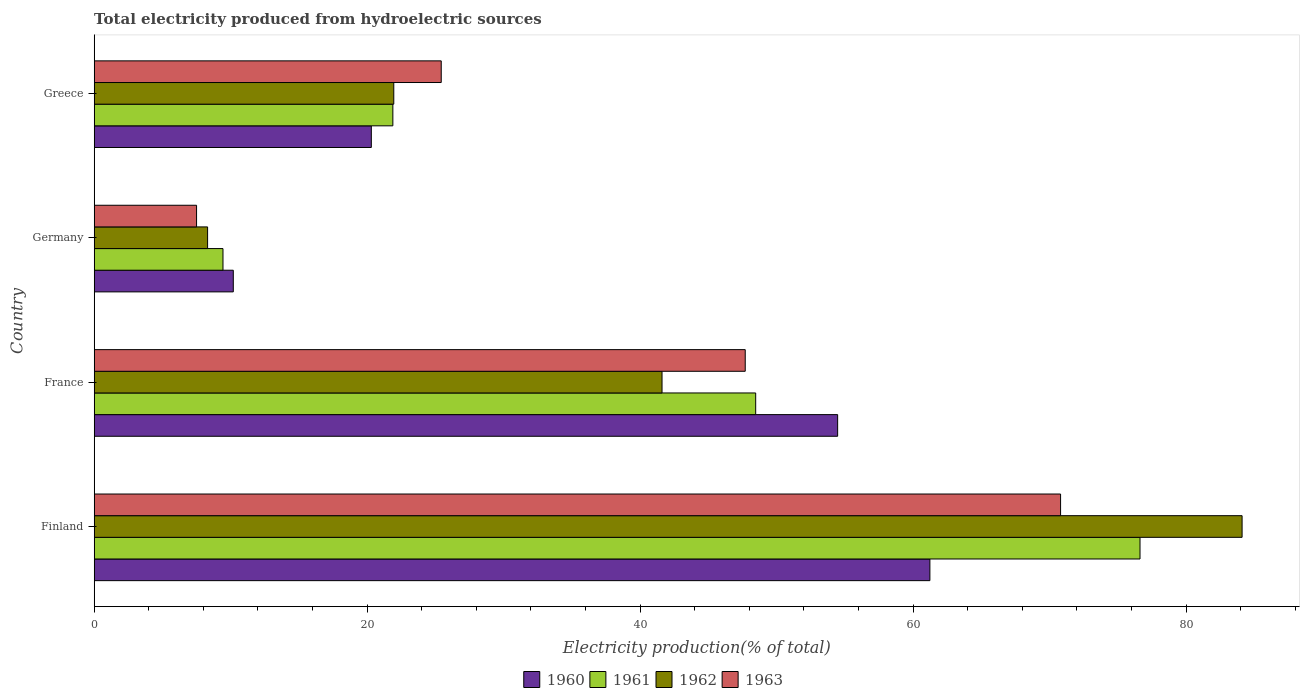How many different coloured bars are there?
Provide a succinct answer. 4. How many groups of bars are there?
Your response must be concise. 4. Are the number of bars on each tick of the Y-axis equal?
Keep it short and to the point. Yes. How many bars are there on the 3rd tick from the top?
Keep it short and to the point. 4. What is the label of the 2nd group of bars from the top?
Provide a short and direct response. Germany. What is the total electricity produced in 1962 in Greece?
Make the answer very short. 21.95. Across all countries, what is the maximum total electricity produced in 1963?
Offer a very short reply. 70.81. Across all countries, what is the minimum total electricity produced in 1963?
Make the answer very short. 7.5. In which country was the total electricity produced in 1963 minimum?
Make the answer very short. Germany. What is the total total electricity produced in 1960 in the graph?
Your response must be concise. 146.2. What is the difference between the total electricity produced in 1963 in Finland and that in France?
Make the answer very short. 23.11. What is the difference between the total electricity produced in 1961 in France and the total electricity produced in 1963 in Finland?
Give a very brief answer. -22.34. What is the average total electricity produced in 1963 per country?
Give a very brief answer. 37.86. What is the difference between the total electricity produced in 1960 and total electricity produced in 1961 in Germany?
Your response must be concise. 0.76. In how many countries, is the total electricity produced in 1960 greater than 84 %?
Keep it short and to the point. 0. What is the ratio of the total electricity produced in 1963 in Finland to that in Germany?
Your answer should be compact. 9.44. What is the difference between the highest and the second highest total electricity produced in 1961?
Your answer should be compact. 28.16. What is the difference between the highest and the lowest total electricity produced in 1962?
Ensure brevity in your answer.  75.8. Is the sum of the total electricity produced in 1960 in Finland and Greece greater than the maximum total electricity produced in 1963 across all countries?
Your answer should be very brief. Yes. What does the 1st bar from the top in France represents?
Your answer should be compact. 1963. Is it the case that in every country, the sum of the total electricity produced in 1960 and total electricity produced in 1963 is greater than the total electricity produced in 1962?
Give a very brief answer. Yes. How many countries are there in the graph?
Your answer should be compact. 4. Where does the legend appear in the graph?
Make the answer very short. Bottom center. How many legend labels are there?
Your response must be concise. 4. How are the legend labels stacked?
Make the answer very short. Horizontal. What is the title of the graph?
Offer a very short reply. Total electricity produced from hydroelectric sources. What is the label or title of the X-axis?
Your answer should be very brief. Electricity production(% of total). What is the label or title of the Y-axis?
Make the answer very short. Country. What is the Electricity production(% of total) in 1960 in Finland?
Give a very brief answer. 61.23. What is the Electricity production(% of total) of 1961 in Finland?
Your response must be concise. 76.63. What is the Electricity production(% of total) in 1962 in Finland?
Your answer should be compact. 84.11. What is the Electricity production(% of total) of 1963 in Finland?
Provide a short and direct response. 70.81. What is the Electricity production(% of total) of 1960 in France?
Offer a very short reply. 54.47. What is the Electricity production(% of total) of 1961 in France?
Make the answer very short. 48.47. What is the Electricity production(% of total) in 1962 in France?
Keep it short and to the point. 41.61. What is the Electricity production(% of total) of 1963 in France?
Your response must be concise. 47.7. What is the Electricity production(% of total) in 1960 in Germany?
Give a very brief answer. 10.19. What is the Electricity production(% of total) in 1961 in Germany?
Offer a very short reply. 9.44. What is the Electricity production(% of total) of 1962 in Germany?
Your answer should be very brief. 8.31. What is the Electricity production(% of total) in 1963 in Germany?
Keep it short and to the point. 7.5. What is the Electricity production(% of total) of 1960 in Greece?
Keep it short and to the point. 20.31. What is the Electricity production(% of total) of 1961 in Greece?
Your answer should be very brief. 21.88. What is the Electricity production(% of total) of 1962 in Greece?
Ensure brevity in your answer.  21.95. What is the Electricity production(% of total) in 1963 in Greece?
Provide a short and direct response. 25.43. Across all countries, what is the maximum Electricity production(% of total) of 1960?
Keep it short and to the point. 61.23. Across all countries, what is the maximum Electricity production(% of total) of 1961?
Provide a succinct answer. 76.63. Across all countries, what is the maximum Electricity production(% of total) in 1962?
Your answer should be very brief. 84.11. Across all countries, what is the maximum Electricity production(% of total) of 1963?
Your answer should be compact. 70.81. Across all countries, what is the minimum Electricity production(% of total) of 1960?
Your answer should be compact. 10.19. Across all countries, what is the minimum Electricity production(% of total) in 1961?
Provide a succinct answer. 9.44. Across all countries, what is the minimum Electricity production(% of total) of 1962?
Provide a short and direct response. 8.31. Across all countries, what is the minimum Electricity production(% of total) in 1963?
Give a very brief answer. 7.5. What is the total Electricity production(% of total) of 1960 in the graph?
Your answer should be compact. 146.2. What is the total Electricity production(% of total) in 1961 in the graph?
Offer a very short reply. 156.42. What is the total Electricity production(% of total) in 1962 in the graph?
Your answer should be compact. 155.97. What is the total Electricity production(% of total) of 1963 in the graph?
Provide a succinct answer. 151.44. What is the difference between the Electricity production(% of total) in 1960 in Finland and that in France?
Your answer should be compact. 6.76. What is the difference between the Electricity production(% of total) in 1961 in Finland and that in France?
Keep it short and to the point. 28.16. What is the difference between the Electricity production(% of total) in 1962 in Finland and that in France?
Make the answer very short. 42.5. What is the difference between the Electricity production(% of total) of 1963 in Finland and that in France?
Provide a succinct answer. 23.11. What is the difference between the Electricity production(% of total) in 1960 in Finland and that in Germany?
Ensure brevity in your answer.  51.04. What is the difference between the Electricity production(% of total) of 1961 in Finland and that in Germany?
Offer a very short reply. 67.19. What is the difference between the Electricity production(% of total) of 1962 in Finland and that in Germany?
Your answer should be compact. 75.8. What is the difference between the Electricity production(% of total) in 1963 in Finland and that in Germany?
Give a very brief answer. 63.31. What is the difference between the Electricity production(% of total) in 1960 in Finland and that in Greece?
Make the answer very short. 40.93. What is the difference between the Electricity production(% of total) of 1961 in Finland and that in Greece?
Make the answer very short. 54.75. What is the difference between the Electricity production(% of total) of 1962 in Finland and that in Greece?
Your response must be concise. 62.16. What is the difference between the Electricity production(% of total) in 1963 in Finland and that in Greece?
Offer a very short reply. 45.38. What is the difference between the Electricity production(% of total) of 1960 in France and that in Germany?
Ensure brevity in your answer.  44.28. What is the difference between the Electricity production(% of total) in 1961 in France and that in Germany?
Provide a succinct answer. 39.03. What is the difference between the Electricity production(% of total) of 1962 in France and that in Germany?
Your response must be concise. 33.3. What is the difference between the Electricity production(% of total) in 1963 in France and that in Germany?
Your answer should be compact. 40.2. What is the difference between the Electricity production(% of total) of 1960 in France and that in Greece?
Your response must be concise. 34.17. What is the difference between the Electricity production(% of total) in 1961 in France and that in Greece?
Ensure brevity in your answer.  26.58. What is the difference between the Electricity production(% of total) in 1962 in France and that in Greece?
Give a very brief answer. 19.66. What is the difference between the Electricity production(% of total) in 1963 in France and that in Greece?
Your response must be concise. 22.27. What is the difference between the Electricity production(% of total) in 1960 in Germany and that in Greece?
Ensure brevity in your answer.  -10.11. What is the difference between the Electricity production(% of total) in 1961 in Germany and that in Greece?
Give a very brief answer. -12.45. What is the difference between the Electricity production(% of total) in 1962 in Germany and that in Greece?
Offer a terse response. -13.64. What is the difference between the Electricity production(% of total) in 1963 in Germany and that in Greece?
Offer a very short reply. -17.93. What is the difference between the Electricity production(% of total) of 1960 in Finland and the Electricity production(% of total) of 1961 in France?
Ensure brevity in your answer.  12.76. What is the difference between the Electricity production(% of total) in 1960 in Finland and the Electricity production(% of total) in 1962 in France?
Give a very brief answer. 19.63. What is the difference between the Electricity production(% of total) of 1960 in Finland and the Electricity production(% of total) of 1963 in France?
Offer a very short reply. 13.53. What is the difference between the Electricity production(% of total) of 1961 in Finland and the Electricity production(% of total) of 1962 in France?
Your answer should be compact. 35.02. What is the difference between the Electricity production(% of total) of 1961 in Finland and the Electricity production(% of total) of 1963 in France?
Offer a very short reply. 28.93. What is the difference between the Electricity production(% of total) in 1962 in Finland and the Electricity production(% of total) in 1963 in France?
Offer a very short reply. 36.41. What is the difference between the Electricity production(% of total) in 1960 in Finland and the Electricity production(% of total) in 1961 in Germany?
Make the answer very short. 51.8. What is the difference between the Electricity production(% of total) of 1960 in Finland and the Electricity production(% of total) of 1962 in Germany?
Your answer should be compact. 52.92. What is the difference between the Electricity production(% of total) in 1960 in Finland and the Electricity production(% of total) in 1963 in Germany?
Your response must be concise. 53.73. What is the difference between the Electricity production(% of total) in 1961 in Finland and the Electricity production(% of total) in 1962 in Germany?
Your answer should be very brief. 68.32. What is the difference between the Electricity production(% of total) in 1961 in Finland and the Electricity production(% of total) in 1963 in Germany?
Ensure brevity in your answer.  69.13. What is the difference between the Electricity production(% of total) of 1962 in Finland and the Electricity production(% of total) of 1963 in Germany?
Your answer should be very brief. 76.61. What is the difference between the Electricity production(% of total) of 1960 in Finland and the Electricity production(% of total) of 1961 in Greece?
Give a very brief answer. 39.35. What is the difference between the Electricity production(% of total) of 1960 in Finland and the Electricity production(% of total) of 1962 in Greece?
Keep it short and to the point. 39.28. What is the difference between the Electricity production(% of total) of 1960 in Finland and the Electricity production(% of total) of 1963 in Greece?
Offer a very short reply. 35.8. What is the difference between the Electricity production(% of total) in 1961 in Finland and the Electricity production(% of total) in 1962 in Greece?
Provide a short and direct response. 54.68. What is the difference between the Electricity production(% of total) of 1961 in Finland and the Electricity production(% of total) of 1963 in Greece?
Give a very brief answer. 51.2. What is the difference between the Electricity production(% of total) of 1962 in Finland and the Electricity production(% of total) of 1963 in Greece?
Offer a terse response. 58.68. What is the difference between the Electricity production(% of total) in 1960 in France and the Electricity production(% of total) in 1961 in Germany?
Provide a short and direct response. 45.04. What is the difference between the Electricity production(% of total) of 1960 in France and the Electricity production(% of total) of 1962 in Germany?
Your answer should be very brief. 46.16. What is the difference between the Electricity production(% of total) of 1960 in France and the Electricity production(% of total) of 1963 in Germany?
Ensure brevity in your answer.  46.97. What is the difference between the Electricity production(% of total) in 1961 in France and the Electricity production(% of total) in 1962 in Germany?
Your answer should be very brief. 40.16. What is the difference between the Electricity production(% of total) in 1961 in France and the Electricity production(% of total) in 1963 in Germany?
Provide a succinct answer. 40.97. What is the difference between the Electricity production(% of total) in 1962 in France and the Electricity production(% of total) in 1963 in Germany?
Keep it short and to the point. 34.11. What is the difference between the Electricity production(% of total) in 1960 in France and the Electricity production(% of total) in 1961 in Greece?
Offer a terse response. 32.59. What is the difference between the Electricity production(% of total) in 1960 in France and the Electricity production(% of total) in 1962 in Greece?
Offer a terse response. 32.52. What is the difference between the Electricity production(% of total) of 1960 in France and the Electricity production(% of total) of 1963 in Greece?
Offer a very short reply. 29.05. What is the difference between the Electricity production(% of total) in 1961 in France and the Electricity production(% of total) in 1962 in Greece?
Your response must be concise. 26.52. What is the difference between the Electricity production(% of total) in 1961 in France and the Electricity production(% of total) in 1963 in Greece?
Provide a succinct answer. 23.04. What is the difference between the Electricity production(% of total) in 1962 in France and the Electricity production(% of total) in 1963 in Greece?
Your response must be concise. 16.18. What is the difference between the Electricity production(% of total) of 1960 in Germany and the Electricity production(% of total) of 1961 in Greece?
Your answer should be compact. -11.69. What is the difference between the Electricity production(% of total) in 1960 in Germany and the Electricity production(% of total) in 1962 in Greece?
Offer a very short reply. -11.76. What is the difference between the Electricity production(% of total) in 1960 in Germany and the Electricity production(% of total) in 1963 in Greece?
Provide a short and direct response. -15.24. What is the difference between the Electricity production(% of total) in 1961 in Germany and the Electricity production(% of total) in 1962 in Greece?
Your response must be concise. -12.51. What is the difference between the Electricity production(% of total) in 1961 in Germany and the Electricity production(% of total) in 1963 in Greece?
Offer a terse response. -15.99. What is the difference between the Electricity production(% of total) in 1962 in Germany and the Electricity production(% of total) in 1963 in Greece?
Make the answer very short. -17.12. What is the average Electricity production(% of total) in 1960 per country?
Your answer should be very brief. 36.55. What is the average Electricity production(% of total) of 1961 per country?
Provide a succinct answer. 39.1. What is the average Electricity production(% of total) of 1962 per country?
Your answer should be very brief. 38.99. What is the average Electricity production(% of total) in 1963 per country?
Keep it short and to the point. 37.86. What is the difference between the Electricity production(% of total) of 1960 and Electricity production(% of total) of 1961 in Finland?
Make the answer very short. -15.4. What is the difference between the Electricity production(% of total) in 1960 and Electricity production(% of total) in 1962 in Finland?
Provide a short and direct response. -22.88. What is the difference between the Electricity production(% of total) in 1960 and Electricity production(% of total) in 1963 in Finland?
Provide a succinct answer. -9.58. What is the difference between the Electricity production(% of total) in 1961 and Electricity production(% of total) in 1962 in Finland?
Your response must be concise. -7.48. What is the difference between the Electricity production(% of total) of 1961 and Electricity production(% of total) of 1963 in Finland?
Offer a very short reply. 5.82. What is the difference between the Electricity production(% of total) in 1962 and Electricity production(% of total) in 1963 in Finland?
Your answer should be very brief. 13.3. What is the difference between the Electricity production(% of total) in 1960 and Electricity production(% of total) in 1961 in France?
Give a very brief answer. 6.01. What is the difference between the Electricity production(% of total) of 1960 and Electricity production(% of total) of 1962 in France?
Your answer should be very brief. 12.87. What is the difference between the Electricity production(% of total) in 1960 and Electricity production(% of total) in 1963 in France?
Provide a succinct answer. 6.77. What is the difference between the Electricity production(% of total) in 1961 and Electricity production(% of total) in 1962 in France?
Offer a terse response. 6.86. What is the difference between the Electricity production(% of total) in 1961 and Electricity production(% of total) in 1963 in France?
Offer a very short reply. 0.77. What is the difference between the Electricity production(% of total) of 1962 and Electricity production(% of total) of 1963 in France?
Your answer should be compact. -6.1. What is the difference between the Electricity production(% of total) of 1960 and Electricity production(% of total) of 1961 in Germany?
Keep it short and to the point. 0.76. What is the difference between the Electricity production(% of total) in 1960 and Electricity production(% of total) in 1962 in Germany?
Provide a succinct answer. 1.88. What is the difference between the Electricity production(% of total) of 1960 and Electricity production(% of total) of 1963 in Germany?
Your answer should be compact. 2.69. What is the difference between the Electricity production(% of total) in 1961 and Electricity production(% of total) in 1962 in Germany?
Your response must be concise. 1.13. What is the difference between the Electricity production(% of total) in 1961 and Electricity production(% of total) in 1963 in Germany?
Provide a succinct answer. 1.94. What is the difference between the Electricity production(% of total) in 1962 and Electricity production(% of total) in 1963 in Germany?
Your response must be concise. 0.81. What is the difference between the Electricity production(% of total) of 1960 and Electricity production(% of total) of 1961 in Greece?
Ensure brevity in your answer.  -1.58. What is the difference between the Electricity production(% of total) of 1960 and Electricity production(% of total) of 1962 in Greece?
Provide a succinct answer. -1.64. What is the difference between the Electricity production(% of total) of 1960 and Electricity production(% of total) of 1963 in Greece?
Give a very brief answer. -5.12. What is the difference between the Electricity production(% of total) of 1961 and Electricity production(% of total) of 1962 in Greece?
Your response must be concise. -0.07. What is the difference between the Electricity production(% of total) in 1961 and Electricity production(% of total) in 1963 in Greece?
Keep it short and to the point. -3.54. What is the difference between the Electricity production(% of total) of 1962 and Electricity production(% of total) of 1963 in Greece?
Keep it short and to the point. -3.48. What is the ratio of the Electricity production(% of total) in 1960 in Finland to that in France?
Your answer should be very brief. 1.12. What is the ratio of the Electricity production(% of total) of 1961 in Finland to that in France?
Your response must be concise. 1.58. What is the ratio of the Electricity production(% of total) in 1962 in Finland to that in France?
Offer a terse response. 2.02. What is the ratio of the Electricity production(% of total) in 1963 in Finland to that in France?
Your answer should be compact. 1.48. What is the ratio of the Electricity production(% of total) in 1960 in Finland to that in Germany?
Keep it short and to the point. 6.01. What is the ratio of the Electricity production(% of total) in 1961 in Finland to that in Germany?
Ensure brevity in your answer.  8.12. What is the ratio of the Electricity production(% of total) in 1962 in Finland to that in Germany?
Offer a terse response. 10.12. What is the ratio of the Electricity production(% of total) of 1963 in Finland to that in Germany?
Your answer should be very brief. 9.44. What is the ratio of the Electricity production(% of total) in 1960 in Finland to that in Greece?
Give a very brief answer. 3.02. What is the ratio of the Electricity production(% of total) of 1961 in Finland to that in Greece?
Give a very brief answer. 3.5. What is the ratio of the Electricity production(% of total) in 1962 in Finland to that in Greece?
Your answer should be very brief. 3.83. What is the ratio of the Electricity production(% of total) of 1963 in Finland to that in Greece?
Give a very brief answer. 2.78. What is the ratio of the Electricity production(% of total) in 1960 in France to that in Germany?
Ensure brevity in your answer.  5.34. What is the ratio of the Electricity production(% of total) of 1961 in France to that in Germany?
Your answer should be compact. 5.14. What is the ratio of the Electricity production(% of total) of 1962 in France to that in Germany?
Ensure brevity in your answer.  5.01. What is the ratio of the Electricity production(% of total) in 1963 in France to that in Germany?
Provide a succinct answer. 6.36. What is the ratio of the Electricity production(% of total) of 1960 in France to that in Greece?
Ensure brevity in your answer.  2.68. What is the ratio of the Electricity production(% of total) in 1961 in France to that in Greece?
Make the answer very short. 2.21. What is the ratio of the Electricity production(% of total) in 1962 in France to that in Greece?
Keep it short and to the point. 1.9. What is the ratio of the Electricity production(% of total) of 1963 in France to that in Greece?
Give a very brief answer. 1.88. What is the ratio of the Electricity production(% of total) of 1960 in Germany to that in Greece?
Give a very brief answer. 0.5. What is the ratio of the Electricity production(% of total) in 1961 in Germany to that in Greece?
Your answer should be very brief. 0.43. What is the ratio of the Electricity production(% of total) of 1962 in Germany to that in Greece?
Your answer should be compact. 0.38. What is the ratio of the Electricity production(% of total) in 1963 in Germany to that in Greece?
Provide a short and direct response. 0.29. What is the difference between the highest and the second highest Electricity production(% of total) of 1960?
Give a very brief answer. 6.76. What is the difference between the highest and the second highest Electricity production(% of total) of 1961?
Offer a terse response. 28.16. What is the difference between the highest and the second highest Electricity production(% of total) in 1962?
Give a very brief answer. 42.5. What is the difference between the highest and the second highest Electricity production(% of total) of 1963?
Provide a short and direct response. 23.11. What is the difference between the highest and the lowest Electricity production(% of total) of 1960?
Make the answer very short. 51.04. What is the difference between the highest and the lowest Electricity production(% of total) of 1961?
Make the answer very short. 67.19. What is the difference between the highest and the lowest Electricity production(% of total) in 1962?
Provide a short and direct response. 75.8. What is the difference between the highest and the lowest Electricity production(% of total) of 1963?
Ensure brevity in your answer.  63.31. 